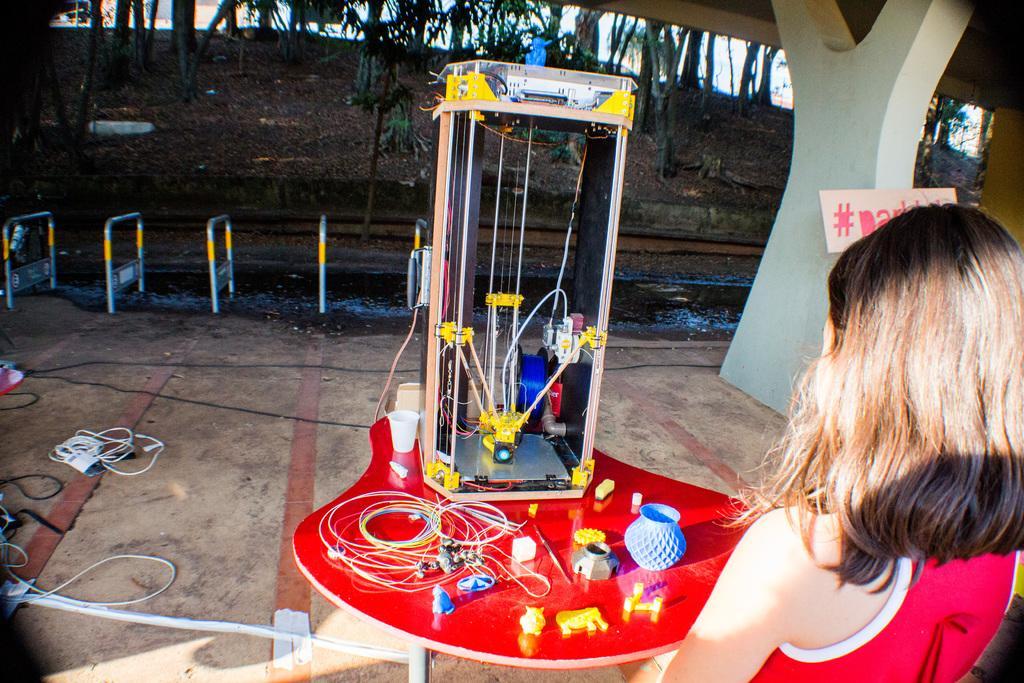Describe this image in one or two sentences. In this image on the right side there is one woman, in the center there is one table. On the table there box wires toys and some other objects, cups, in the background there are some poles, wires, pipe, pillar, trees and sand. And in the center of the image there is some water flowing, on the right side there is one board on the pillar. 